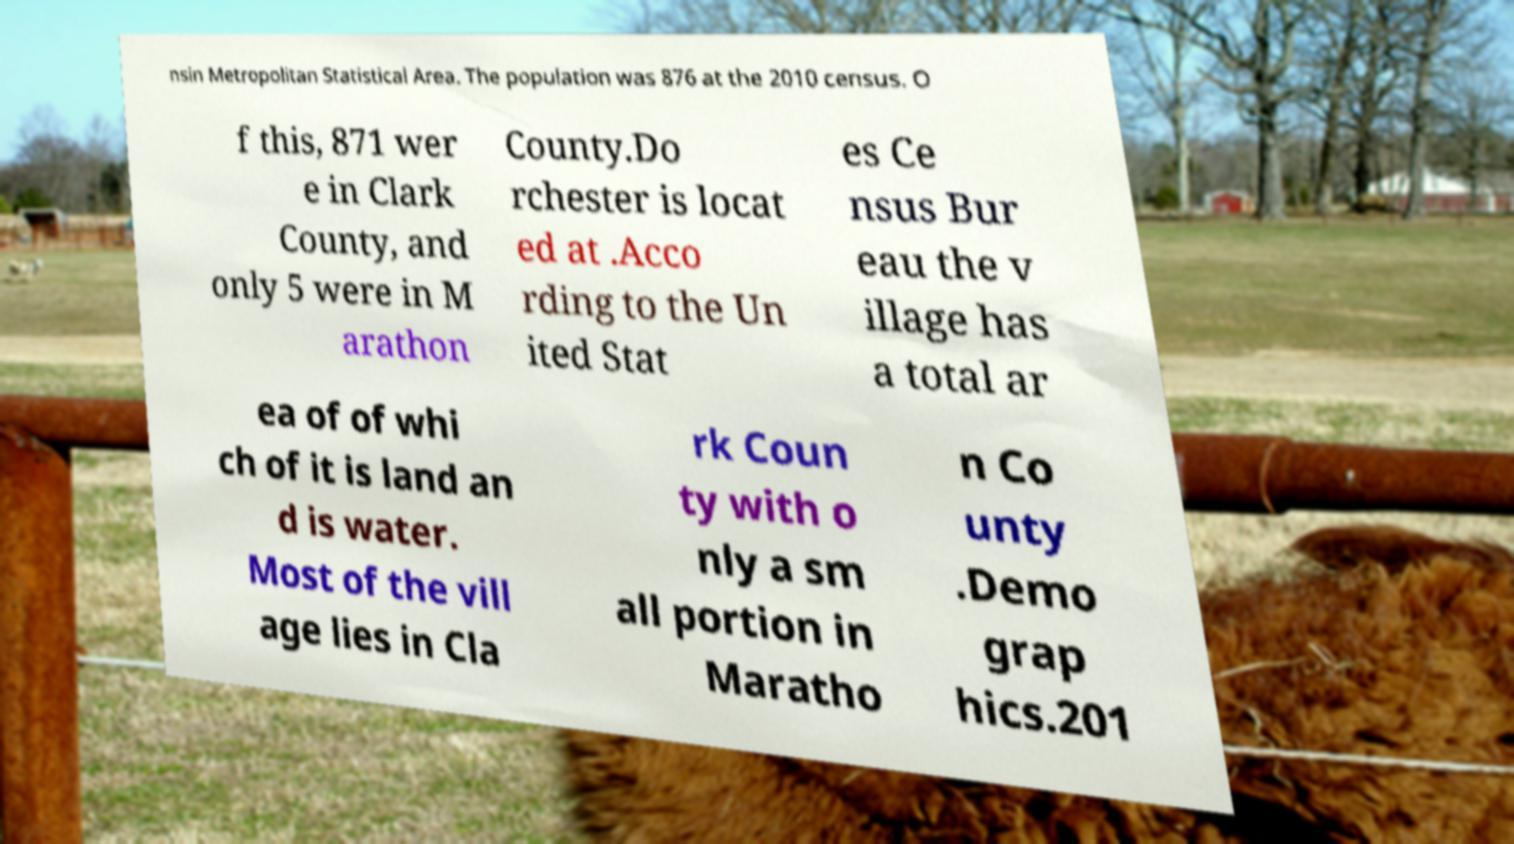Could you extract and type out the text from this image? nsin Metropolitan Statistical Area. The population was 876 at the 2010 census. O f this, 871 wer e in Clark County, and only 5 were in M arathon County.Do rchester is locat ed at .Acco rding to the Un ited Stat es Ce nsus Bur eau the v illage has a total ar ea of of whi ch of it is land an d is water. Most of the vill age lies in Cla rk Coun ty with o nly a sm all portion in Maratho n Co unty .Demo grap hics.201 